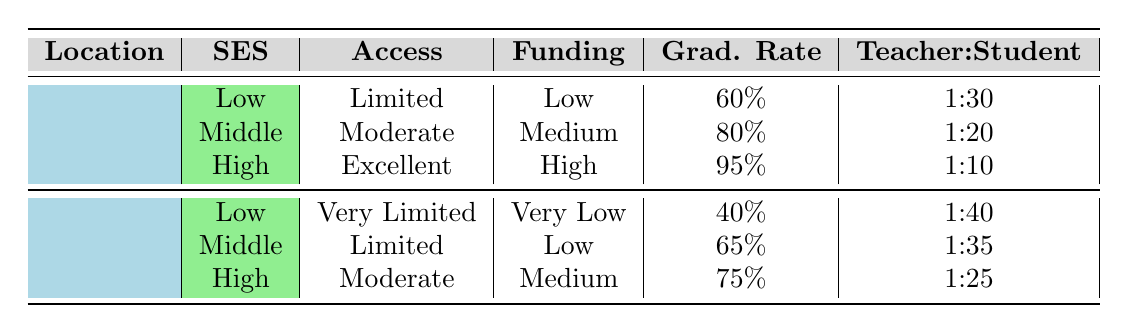What is the access to education for low socio-economic status in urban areas? In the urban section of the table, the row corresponding to low socio-economic status indicates that access to education is "Limited."
Answer: Limited What is the graduation rate for high socio-economic status in rural areas? The row for high socio-economic status in rural areas shows a graduation rate of 75%.
Answer: 75% Is the teacher-student ratio for low socio-economic status in rural areas better than in urban areas? The teacher-student ratio for low socio-economic status in rural areas is 1:40, while in urban areas it is 1:30. Since 1:40 indicates more students per teacher compared to 1:30, the ratio in rural areas is worse.
Answer: No What is the difference in school funding between middle socio-economic status in urban and rural areas? In urban areas, school funding for middle socio-economic status is "Medium," while in rural areas it is "Low." The difference in funding classification means urban areas have better funding than rural areas for this socio-economic group.
Answer: Better funding in urban What is the average graduation rate across all socio-economic statuses in urban areas? The graduation rates for urban areas are: 60% (low), 80% (middle), and 95% (high). To find the average: (60 + 80 + 95) / 3 = 78.33%. Thus, the average graduation rate is approximately 78.33%.
Answer: 78.33% Is the access to education for high socio-economic status in urban areas better than in rural areas? In urban areas, access is "Excellent" for high socio-economic status, whereas in rural areas, it is "Moderate." Since "Excellent" is a higher classification than "Moderate," access is indeed better in urban areas.
Answer: Yes What is the teacher-student ratio for middle socio-economic status in both urban and rural areas, and which is better? The teacher-student ratio for middle socio-economic status in urban areas is 1:20, while in rural areas it is 1:35. A lower ratio indicates fewer students per teacher, thus the urban area has a better ratio.
Answer: Urban has a better ratio What is the total number of access categories represented in the table for urban areas? The access levels for urban areas listed in the table are: Limited, Moderate, and Excellent, which gives us a total of 3 distinct categories.
Answer: 3 What percentage of graduation rate is associated with low socio-economic status in rural areas? The row for low socio-economic status in rural areas specifies a graduation rate of 40%.
Answer: 40% 